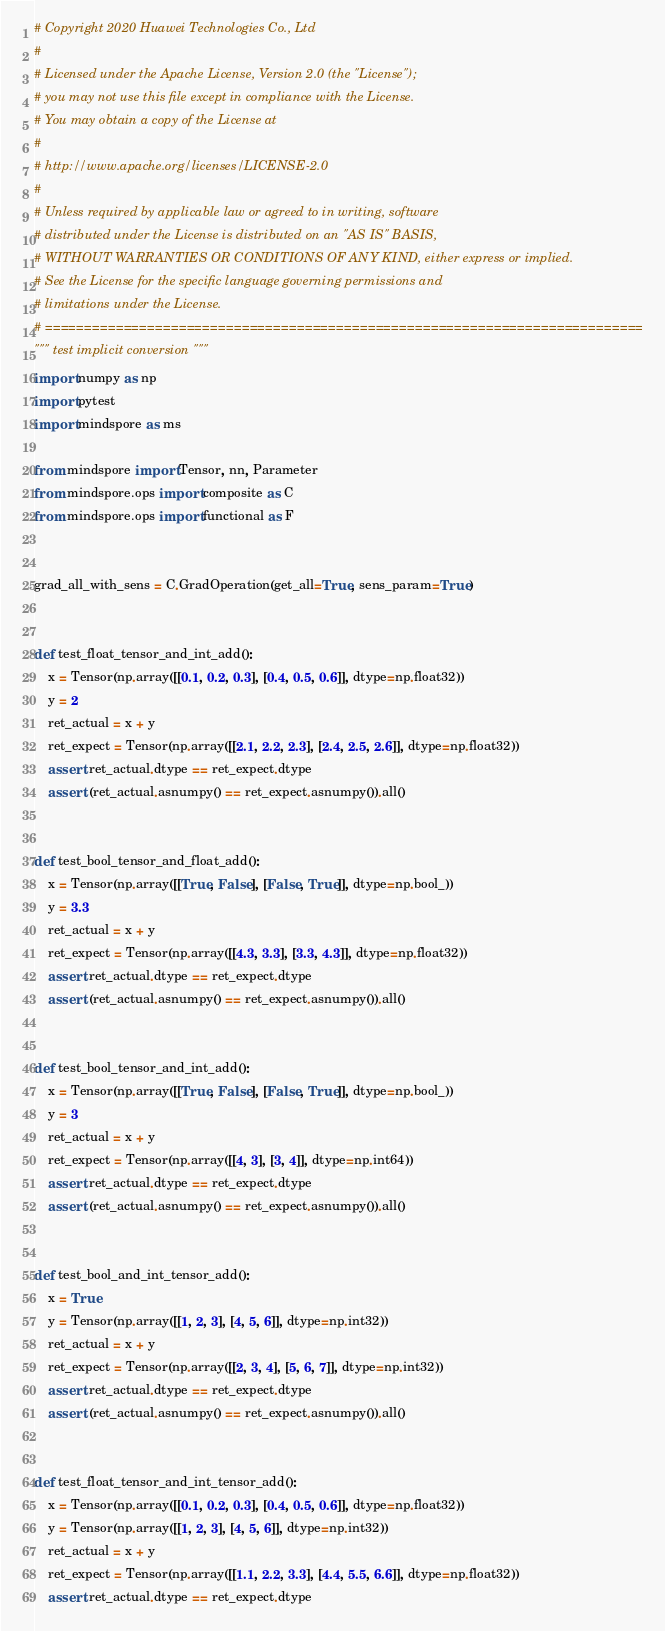Convert code to text. <code><loc_0><loc_0><loc_500><loc_500><_Python_># Copyright 2020 Huawei Technologies Co., Ltd
#
# Licensed under the Apache License, Version 2.0 (the "License");
# you may not use this file except in compliance with the License.
# You may obtain a copy of the License at
#
# http://www.apache.org/licenses/LICENSE-2.0
#
# Unless required by applicable law or agreed to in writing, software
# distributed under the License is distributed on an "AS IS" BASIS,
# WITHOUT WARRANTIES OR CONDITIONS OF ANY KIND, either express or implied.
# See the License for the specific language governing permissions and
# limitations under the License.
# ============================================================================
""" test implicit conversion """
import numpy as np
import pytest
import mindspore as ms

from mindspore import Tensor, nn, Parameter
from mindspore.ops import composite as C
from mindspore.ops import functional as F


grad_all_with_sens = C.GradOperation(get_all=True, sens_param=True)


def test_float_tensor_and_int_add():
    x = Tensor(np.array([[0.1, 0.2, 0.3], [0.4, 0.5, 0.6]], dtype=np.float32))
    y = 2
    ret_actual = x + y
    ret_expect = Tensor(np.array([[2.1, 2.2, 2.3], [2.4, 2.5, 2.6]], dtype=np.float32))
    assert ret_actual.dtype == ret_expect.dtype
    assert (ret_actual.asnumpy() == ret_expect.asnumpy()).all()


def test_bool_tensor_and_float_add():
    x = Tensor(np.array([[True, False], [False, True]], dtype=np.bool_))
    y = 3.3
    ret_actual = x + y
    ret_expect = Tensor(np.array([[4.3, 3.3], [3.3, 4.3]], dtype=np.float32))
    assert ret_actual.dtype == ret_expect.dtype
    assert (ret_actual.asnumpy() == ret_expect.asnumpy()).all()


def test_bool_tensor_and_int_add():
    x = Tensor(np.array([[True, False], [False, True]], dtype=np.bool_))
    y = 3
    ret_actual = x + y
    ret_expect = Tensor(np.array([[4, 3], [3, 4]], dtype=np.int64))
    assert ret_actual.dtype == ret_expect.dtype
    assert (ret_actual.asnumpy() == ret_expect.asnumpy()).all()


def test_bool_and_int_tensor_add():
    x = True
    y = Tensor(np.array([[1, 2, 3], [4, 5, 6]], dtype=np.int32))
    ret_actual = x + y
    ret_expect = Tensor(np.array([[2, 3, 4], [5, 6, 7]], dtype=np.int32))
    assert ret_actual.dtype == ret_expect.dtype
    assert (ret_actual.asnumpy() == ret_expect.asnumpy()).all()


def test_float_tensor_and_int_tensor_add():
    x = Tensor(np.array([[0.1, 0.2, 0.3], [0.4, 0.5, 0.6]], dtype=np.float32))
    y = Tensor(np.array([[1, 2, 3], [4, 5, 6]], dtype=np.int32))
    ret_actual = x + y
    ret_expect = Tensor(np.array([[1.1, 2.2, 3.3], [4.4, 5.5, 6.6]], dtype=np.float32))
    assert ret_actual.dtype == ret_expect.dtype</code> 